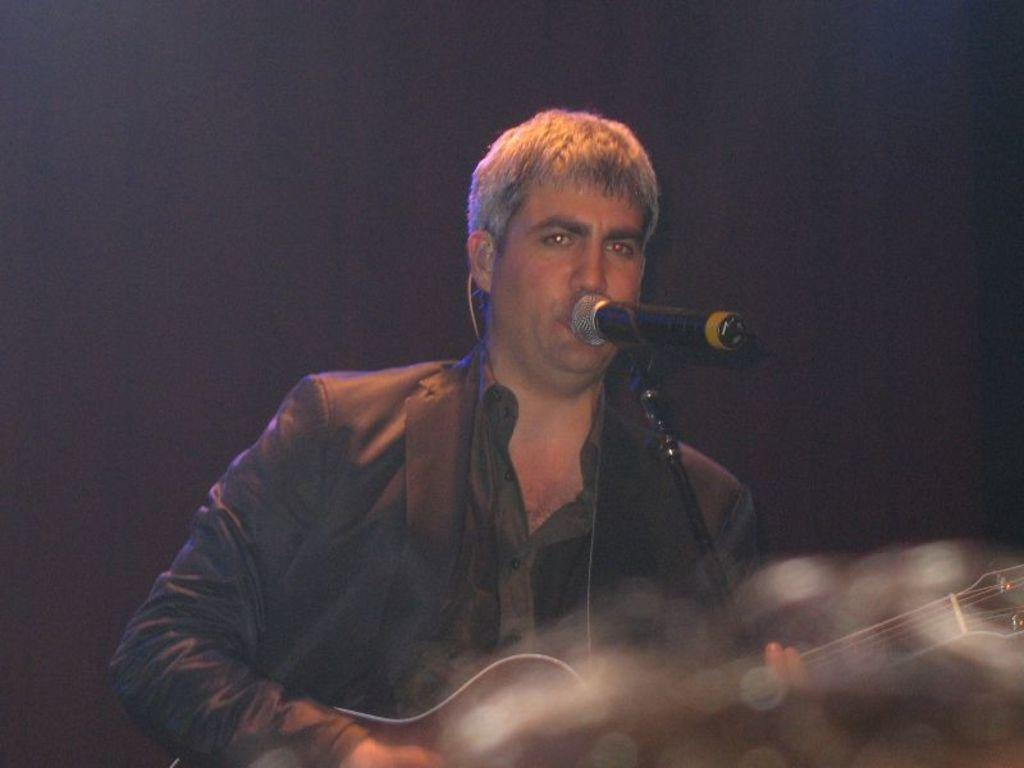Who is the main subject in the image? There is a man in the image. What is the man doing in the image? The man is singing. What object is the man holding in the image? The man is holding a microphone. How is the man dressed in the image? The man is wearing a coat and shirt. What type of birthday cake is on the tray in the image? There is no birthday cake or tray present in the image. In which direction is the man facing in the image? The provided facts do not specify the direction the man is facing in the image. 